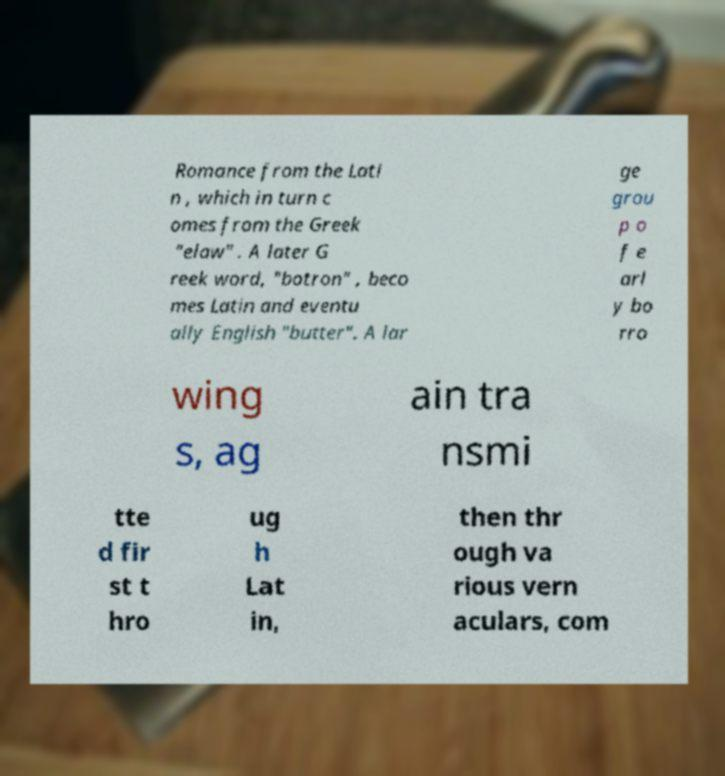I need the written content from this picture converted into text. Can you do that? Romance from the Lati n , which in turn c omes from the Greek "elaw" . A later G reek word, "botron" , beco mes Latin and eventu ally English "butter". A lar ge grou p o f e arl y bo rro wing s, ag ain tra nsmi tte d fir st t hro ug h Lat in, then thr ough va rious vern aculars, com 